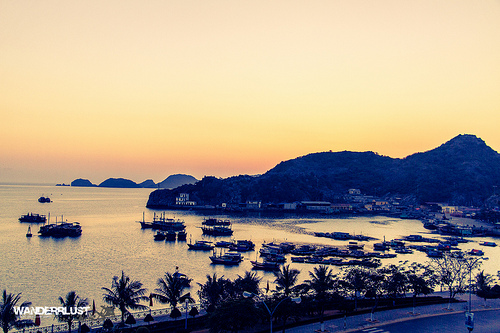<image>
Can you confirm if the sky is behind the mountain? Yes. From this viewpoint, the sky is positioned behind the mountain, with the mountain partially or fully occluding the sky. Where is the water in relation to the rock? Is it under the rock? Yes. The water is positioned underneath the rock, with the rock above it in the vertical space. 